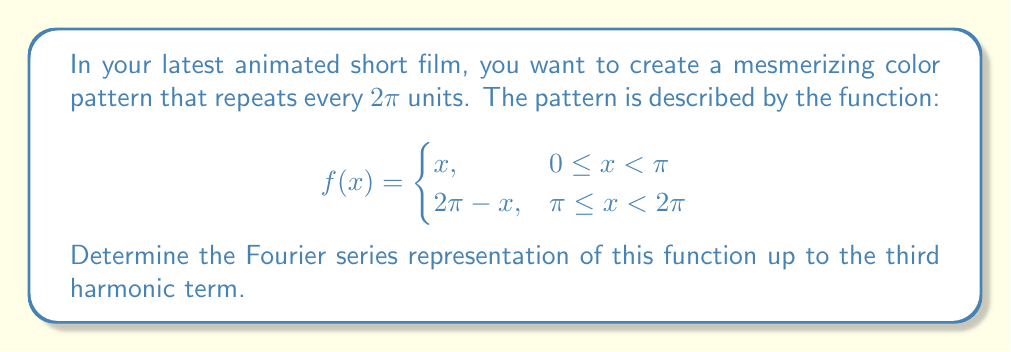Show me your answer to this math problem. To find the Fourier series, we need to calculate the Fourier coefficients $a_0$, $a_n$, and $b_n$.

1. Calculate $a_0$:
   $$a_0 = \frac{1}{\pi} \int_0^{2\pi} f(x) dx = \frac{1}{\pi} \left(\int_0^{\pi} x dx + \int_{\pi}^{2\pi} (2\pi - x) dx\right) = \pi$$

2. Calculate $a_n$:
   $$a_n = \frac{1}{\pi} \int_0^{2\pi} f(x) \cos(nx) dx$$
   For $n \geq 1$, after integration by parts:
   $$a_n = \frac{2}{n^2\pi}(\cos(n\pi) - 1)$$

3. Calculate $b_n$:
   $$b_n = \frac{1}{\pi} \int_0^{2\pi} f(x) \sin(nx) dx$$
   For $n \geq 1$, after integration by parts:
   $$b_n = -\frac{2}{n\pi}\sin(n\pi) = 0$$

4. The Fourier series up to the third harmonic is:
   $$f(x) \approx \frac{a_0}{2} + \sum_{n=1}^3 (a_n \cos(nx) + b_n \sin(nx))$$

   Substituting the values:
   $$f(x) \approx \frac{\pi}{2} + \frac{2}{\pi}\cos(x) - \frac{2}{4\pi}\cos(2x) + \frac{2}{9\pi}\cos(3x)$$
Answer: $$f(x) \approx \frac{\pi}{2} + \frac{2}{\pi}\cos(x) - \frac{1}{2\pi}\cos(2x) + \frac{2}{9\pi}\cos(3x)$$ 